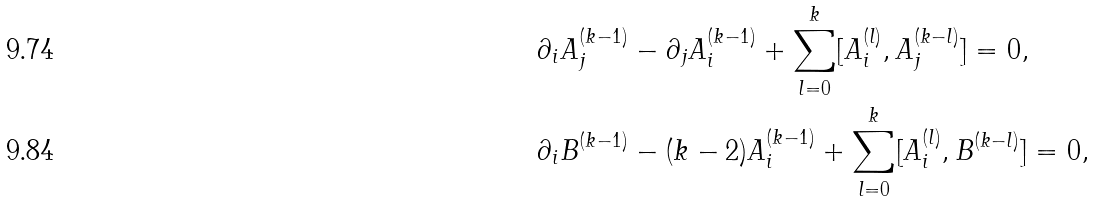Convert formula to latex. <formula><loc_0><loc_0><loc_500><loc_500>& \partial _ { i } A _ { j } ^ { ( k - 1 ) } - \partial _ { j } A _ { i } ^ { ( k - 1 ) } + \sum _ { l = 0 } ^ { k } [ A _ { i } ^ { ( l ) } , A _ { j } ^ { ( k - l ) } ] = 0 , \\ & \partial _ { i } B ^ { ( k - 1 ) } - ( k - 2 ) A _ { i } ^ { ( k - 1 ) } + \sum _ { l = 0 } ^ { k } [ A _ { i } ^ { ( l ) } , B ^ { ( k - l ) } ] = 0 ,</formula> 